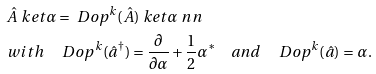<formula> <loc_0><loc_0><loc_500><loc_500>& \hat { A } \ k e t { \alpha } = \ D o p ^ { k } ( \hat { A } ) \ k e t { \alpha } \ n n \\ & w i t h \quad \ D o p ^ { k } ( \hat { a } ^ { \dagger } ) = \frac { \partial } { \partial \alpha } + \frac { 1 } { 2 } \alpha ^ { * } \quad a n d \quad \ D o p ^ { k } ( \hat { a } ) = \alpha .</formula> 